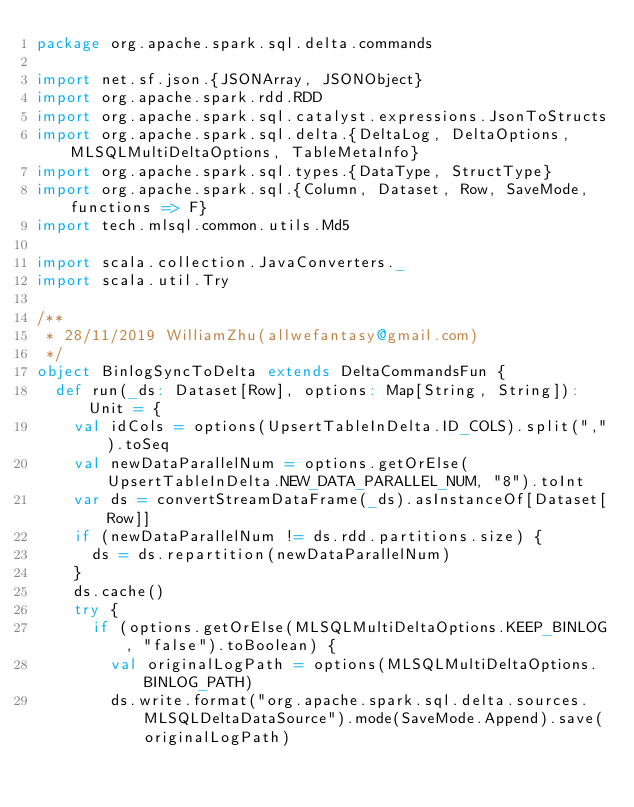<code> <loc_0><loc_0><loc_500><loc_500><_Scala_>package org.apache.spark.sql.delta.commands

import net.sf.json.{JSONArray, JSONObject}
import org.apache.spark.rdd.RDD
import org.apache.spark.sql.catalyst.expressions.JsonToStructs
import org.apache.spark.sql.delta.{DeltaLog, DeltaOptions, MLSQLMultiDeltaOptions, TableMetaInfo}
import org.apache.spark.sql.types.{DataType, StructType}
import org.apache.spark.sql.{Column, Dataset, Row, SaveMode, functions => F}
import tech.mlsql.common.utils.Md5

import scala.collection.JavaConverters._
import scala.util.Try

/**
 * 28/11/2019 WilliamZhu(allwefantasy@gmail.com)
 */
object BinlogSyncToDelta extends DeltaCommandsFun {
  def run(_ds: Dataset[Row], options: Map[String, String]): Unit = {
    val idCols = options(UpsertTableInDelta.ID_COLS).split(",").toSeq
    val newDataParallelNum = options.getOrElse(UpsertTableInDelta.NEW_DATA_PARALLEL_NUM, "8").toInt
    var ds = convertStreamDataFrame(_ds).asInstanceOf[Dataset[Row]]
    if (newDataParallelNum != ds.rdd.partitions.size) {
      ds = ds.repartition(newDataParallelNum)
    }
    ds.cache()
    try {
      if (options.getOrElse(MLSQLMultiDeltaOptions.KEEP_BINLOG, "false").toBoolean) {
        val originalLogPath = options(MLSQLMultiDeltaOptions.BINLOG_PATH)
        ds.write.format("org.apache.spark.sql.delta.sources.MLSQLDeltaDataSource").mode(SaveMode.Append).save(originalLogPath)</code> 